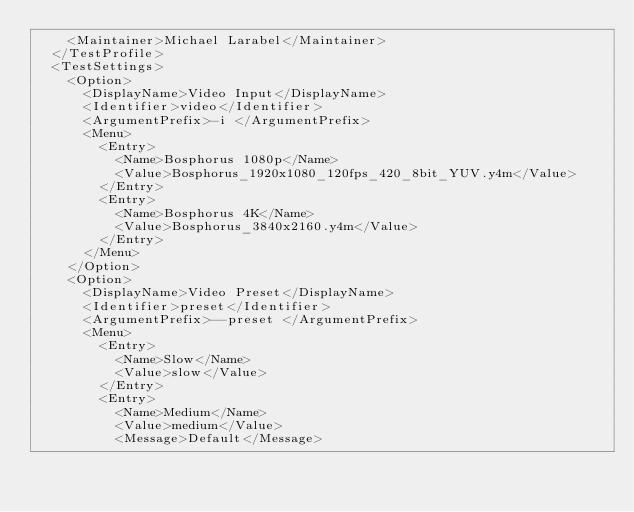<code> <loc_0><loc_0><loc_500><loc_500><_XML_>    <Maintainer>Michael Larabel</Maintainer>
  </TestProfile>
  <TestSettings>
    <Option>
      <DisplayName>Video Input</DisplayName>
      <Identifier>video</Identifier>
      <ArgumentPrefix>-i </ArgumentPrefix>
      <Menu>
        <Entry>
          <Name>Bosphorus 1080p</Name>
          <Value>Bosphorus_1920x1080_120fps_420_8bit_YUV.y4m</Value>
        </Entry>
        <Entry>
          <Name>Bosphorus 4K</Name>
          <Value>Bosphorus_3840x2160.y4m</Value>
        </Entry>
      </Menu>
    </Option>
    <Option>
      <DisplayName>Video Preset</DisplayName>
      <Identifier>preset</Identifier>
      <ArgumentPrefix>--preset </ArgumentPrefix>
      <Menu>
        <Entry>
          <Name>Slow</Name>
          <Value>slow</Value>
        </Entry>
        <Entry>
          <Name>Medium</Name>
          <Value>medium</Value>
          <Message>Default</Message></code> 